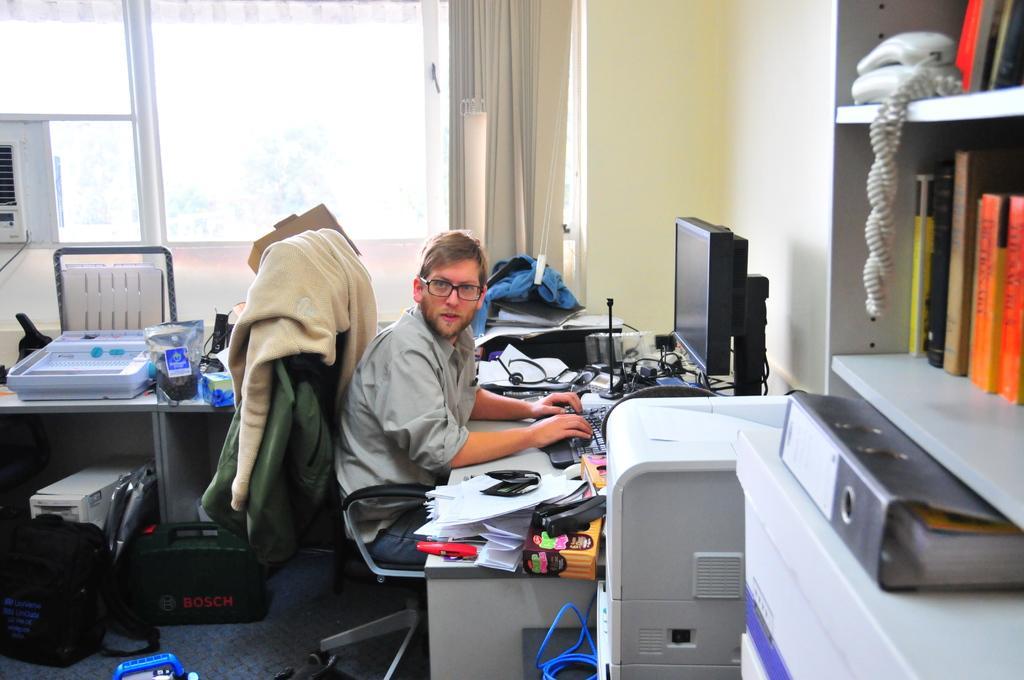Can you describe this image briefly? In this image I can see a man is sitting on the chair. on the table there is a system,paper and some objects. On the floor there is a bag. 